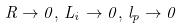<formula> <loc_0><loc_0><loc_500><loc_500>R \rightarrow 0 , \, L _ { i } \rightarrow 0 , \, l _ { p } \rightarrow 0</formula> 